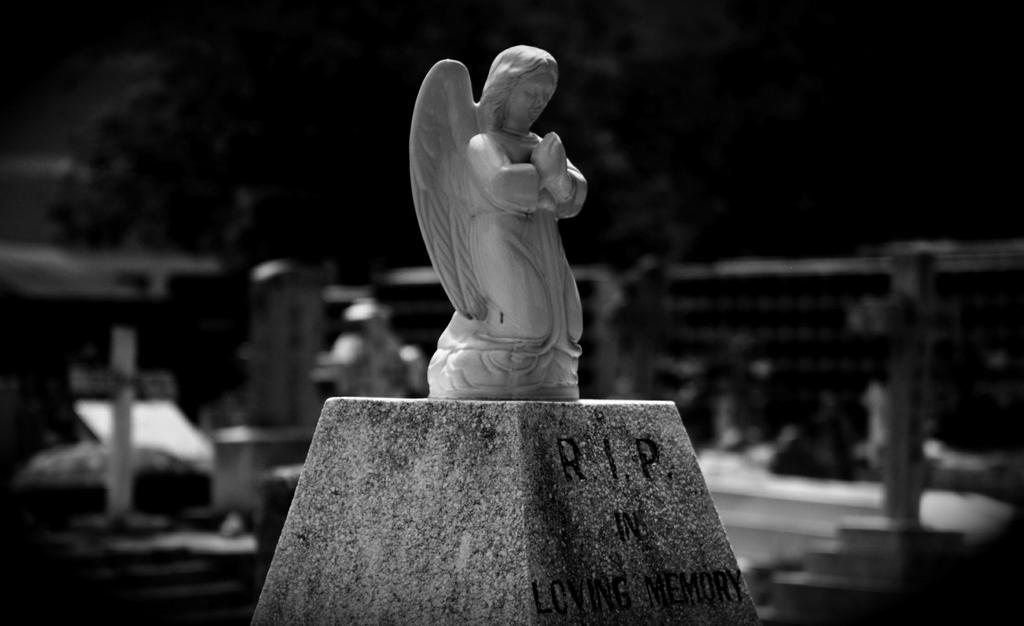What is the color scheme of the image? The image is black and white. What can be seen in the middle of the image? There is a small statue in the middle of the image. How many dimes are scattered around the small statue in the image? There are no dimes present in the image; it only features a small statue. What type of yarn is being used to create the small statue in the image? The image is black and white, and there is no indication of yarn being used to create the small statue. 